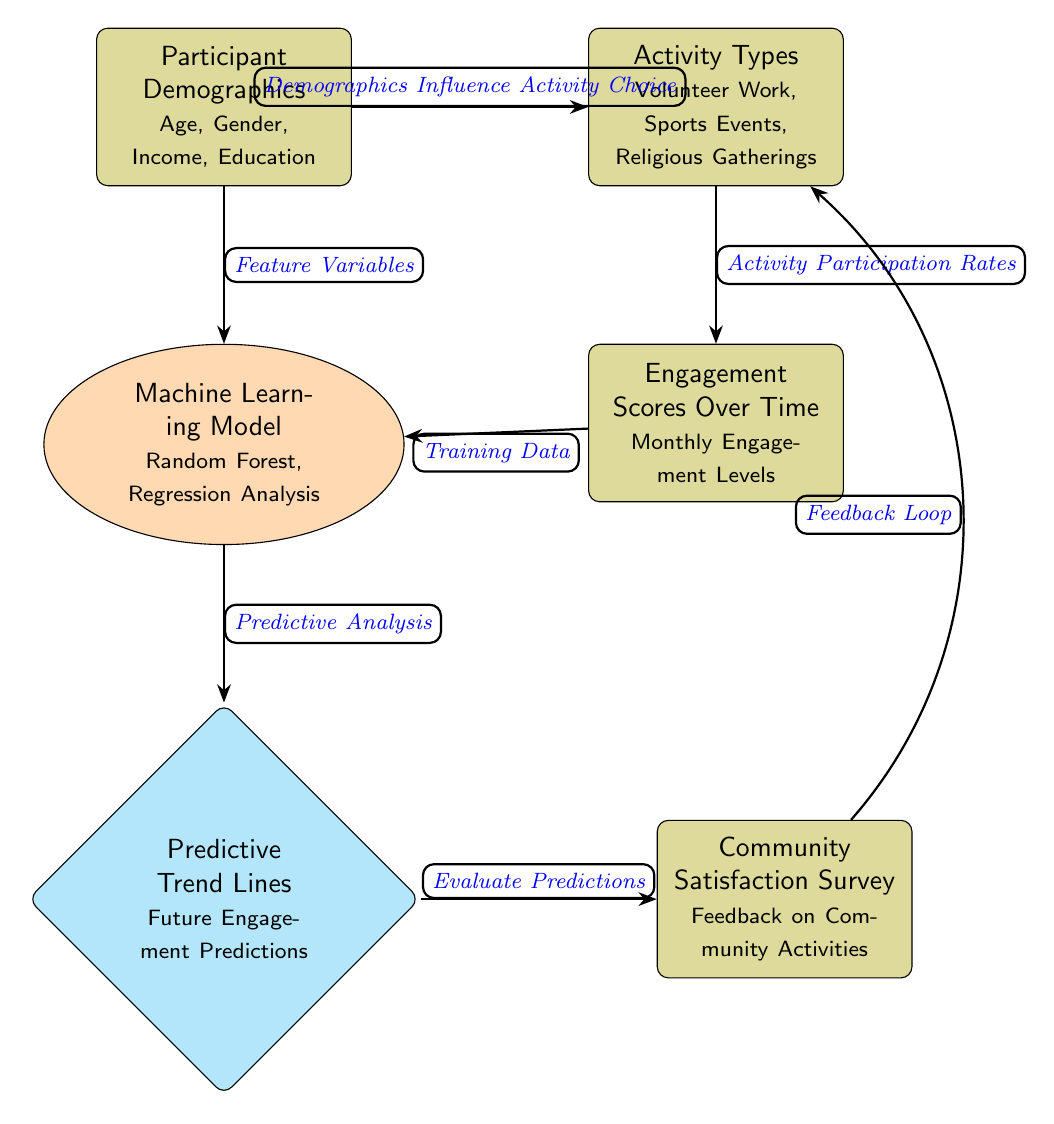What do the participant demographics include? The node labeled "Participant Demographics" lists the categories "Age, Gender, Income, Education." These are the demographic factors impacting the analysis of community engagement.
Answer: Age, Gender, Income, Education How many types of activities are represented? The "Activity Types" node mentions three types of activities: "Volunteer Work, Sports Events, Religious Gatherings," thus there are three types presented in the diagram.
Answer: Three What is the machine learning model used? The node labeled "Machine Learning Model" states "Random Forest, Regression Analysis," indicating the models being utilized in the predictive analysis.
Answer: Random Forest, Regression Analysis What does the feedback loop connect? The feedback loop connects "Community Satisfaction Survey" to "Activity Types," indicating that insights from the survey impact the choice of activities.
Answer: Community Satisfaction Survey and Activity Types How does demographics influence activity choice? There is an arrow labeled "Demographics Influence Activity Choice" from the demographics node to the activities node, indicating that demographic factors determine the types of community activities participants prefer.
Answer: Demographics What does the predictive trend lines node represent? The "Predictive Trend Lines" node describes "Future Engagement Predictions," indicating that it provides insights on expected levels of community engagement based on past data.
Answer: Future Engagement Predictions Why are engagement scores essential for training the model? The "Engagement Scores Over Time" node is labeled as "Training Data" for the machine learning model, implying that these scores are critical to develop accurate predictive analytics.
Answer: Training Data How are future engagement predictions evaluated? The arrow leading to the "Community Satisfaction Survey" from the "Predictive Trend Lines" node signifies that the evaluation of predictions is based on feedback collected from the community regarding their activities.
Answer: Community Satisfaction Survey What type of analyses is indicated by the machine learning model? The "Machine Learning Model" node references "Random Forest, Regression Analysis," suggesting the analyses performed to understand community engagement trends.
Answer: Random Forest, Regression Analysis 